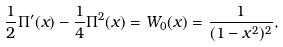Convert formula to latex. <formula><loc_0><loc_0><loc_500><loc_500>\frac { 1 } { 2 } \Pi ^ { \prime } ( x ) - \frac { 1 } { 4 } \Pi ^ { 2 } ( x ) = W _ { 0 } ( x ) = \frac { 1 } { ( 1 - x ^ { 2 } ) ^ { 2 } } ,</formula> 